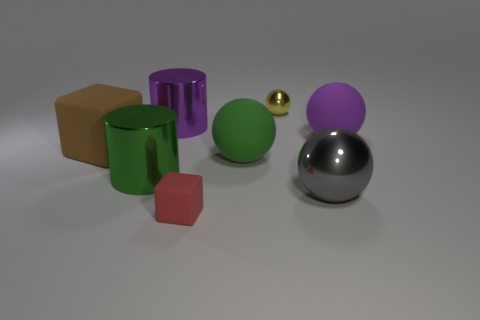Is the number of big gray metallic things less than the number of large red balls?
Your answer should be compact. No. What is the material of the large purple object that is the same shape as the large green shiny thing?
Offer a terse response. Metal. Are there more small red rubber things than tiny objects?
Your response must be concise. No. Is the material of the big purple sphere the same as the small object that is on the right side of the tiny red block?
Your answer should be very brief. No. How many big metallic objects are to the right of the metallic sphere behind the metallic sphere in front of the green sphere?
Keep it short and to the point. 1. Is the number of small red matte objects behind the gray ball less than the number of brown blocks right of the large block?
Offer a terse response. No. How many other objects are there of the same material as the yellow ball?
Keep it short and to the point. 3. There is a red cube that is the same size as the yellow thing; what is it made of?
Keep it short and to the point. Rubber. How many yellow objects are either rubber balls or metal balls?
Your answer should be very brief. 1. What color is the ball that is on the left side of the gray shiny object and behind the brown matte cube?
Make the answer very short. Yellow. 